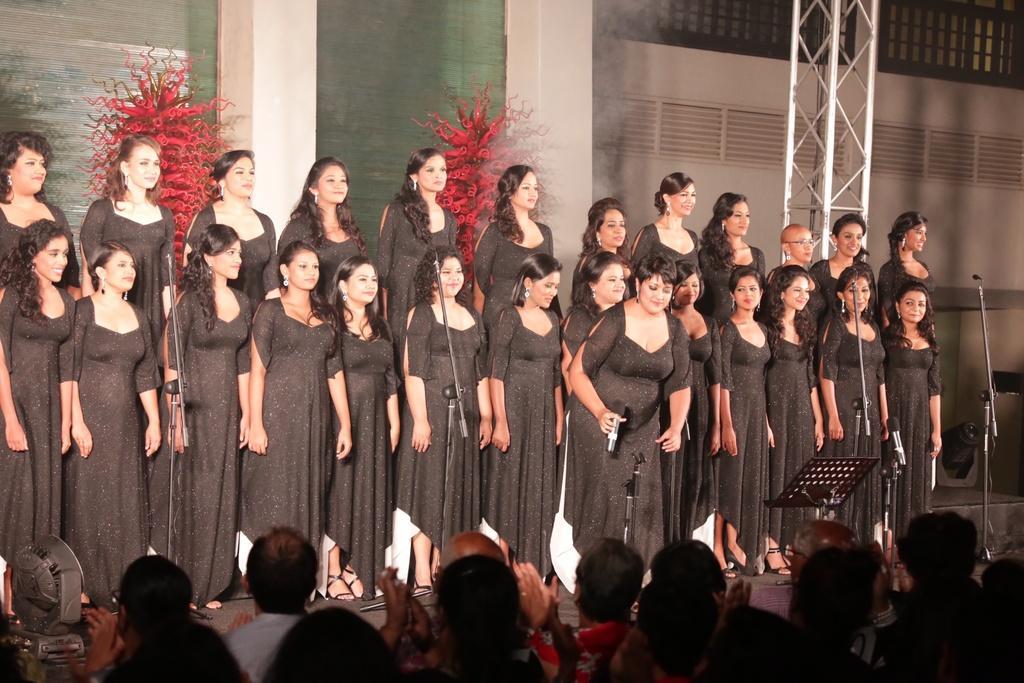Can you describe this image briefly? In this image we can see some women standing on the stage. And we can see the microphones and lights. In the background, we can see the glass doors and some decorative things. On the right, we can see the metal framing and the audience. 